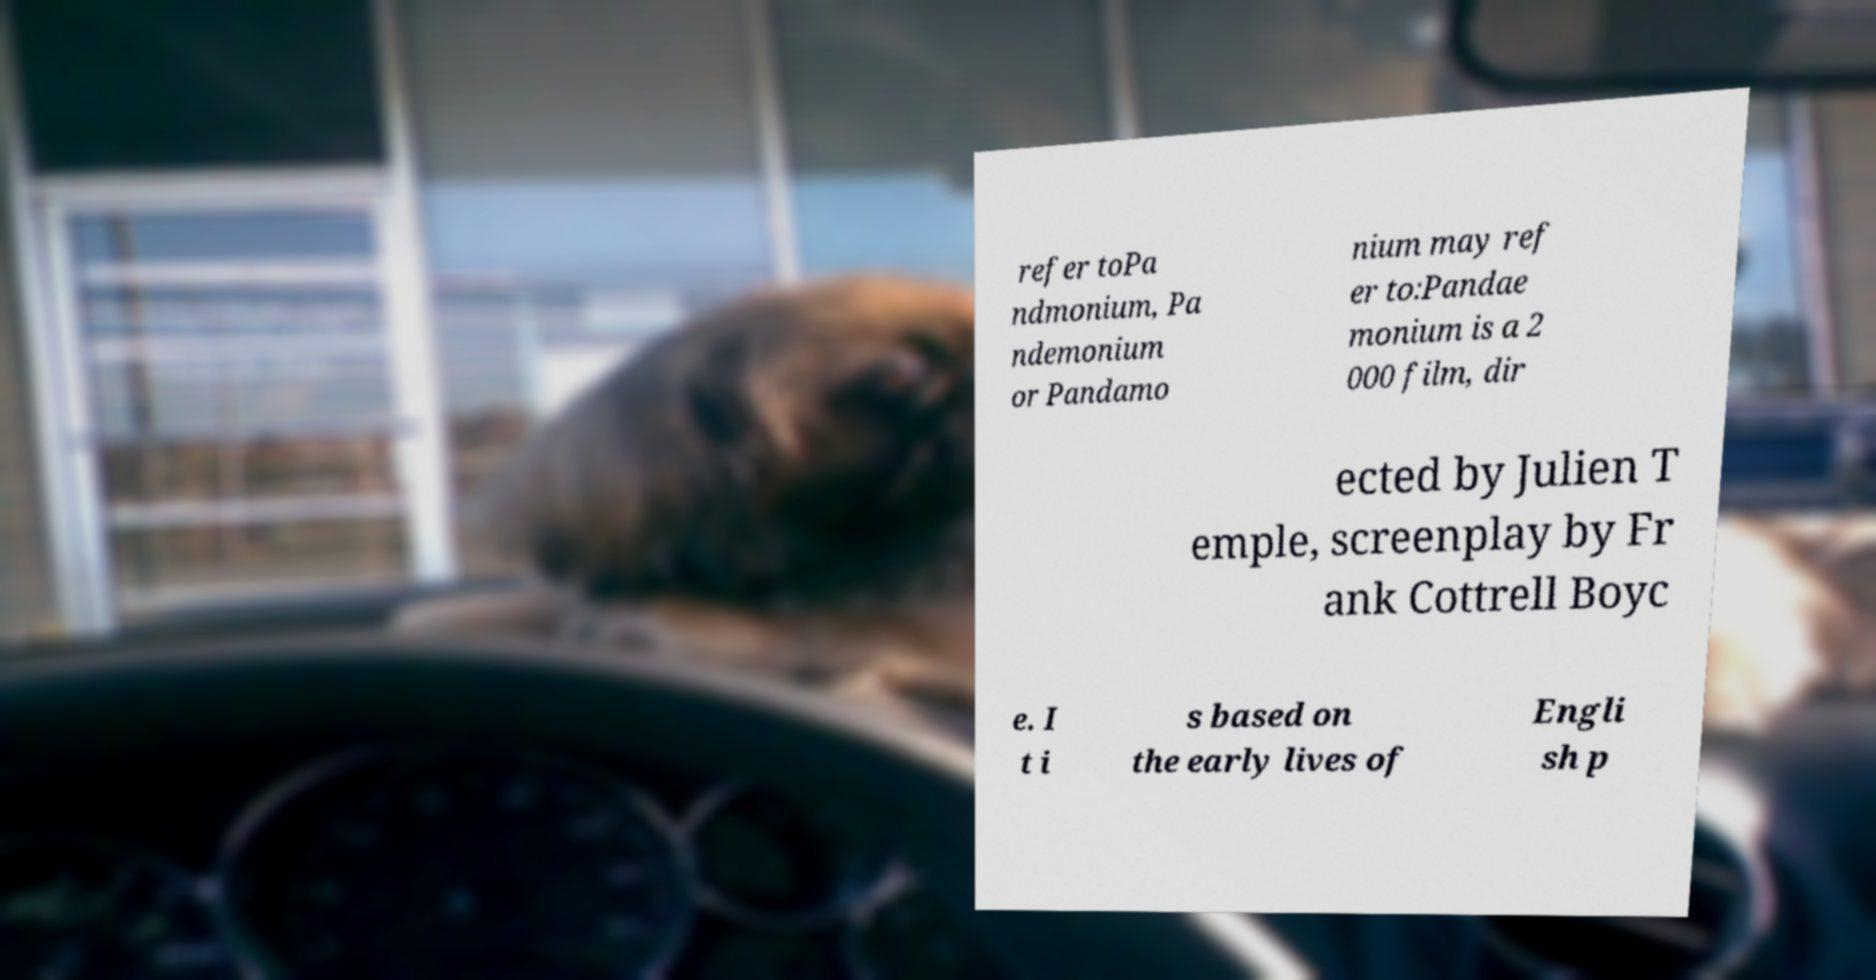Please identify and transcribe the text found in this image. refer toPa ndmonium, Pa ndemonium or Pandamo nium may ref er to:Pandae monium is a 2 000 film, dir ected by Julien T emple, screenplay by Fr ank Cottrell Boyc e. I t i s based on the early lives of Engli sh p 